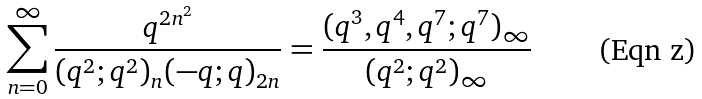Convert formula to latex. <formula><loc_0><loc_0><loc_500><loc_500>\sum _ { n = 0 } ^ { \infty } \frac { q ^ { 2 n ^ { 2 } } } { ( q ^ { 2 } ; q ^ { 2 } ) _ { n } ( - q ; q ) _ { 2 n } } = \frac { ( q ^ { 3 } , q ^ { 4 } , q ^ { 7 } ; q ^ { 7 } ) _ { \infty } } { ( q ^ { 2 } ; q ^ { 2 } ) _ { \infty } }</formula> 